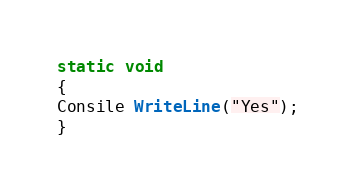Convert code to text. <code><loc_0><loc_0><loc_500><loc_500><_C#_>static void
{
Consile WriteLine("Yes");
}</code> 